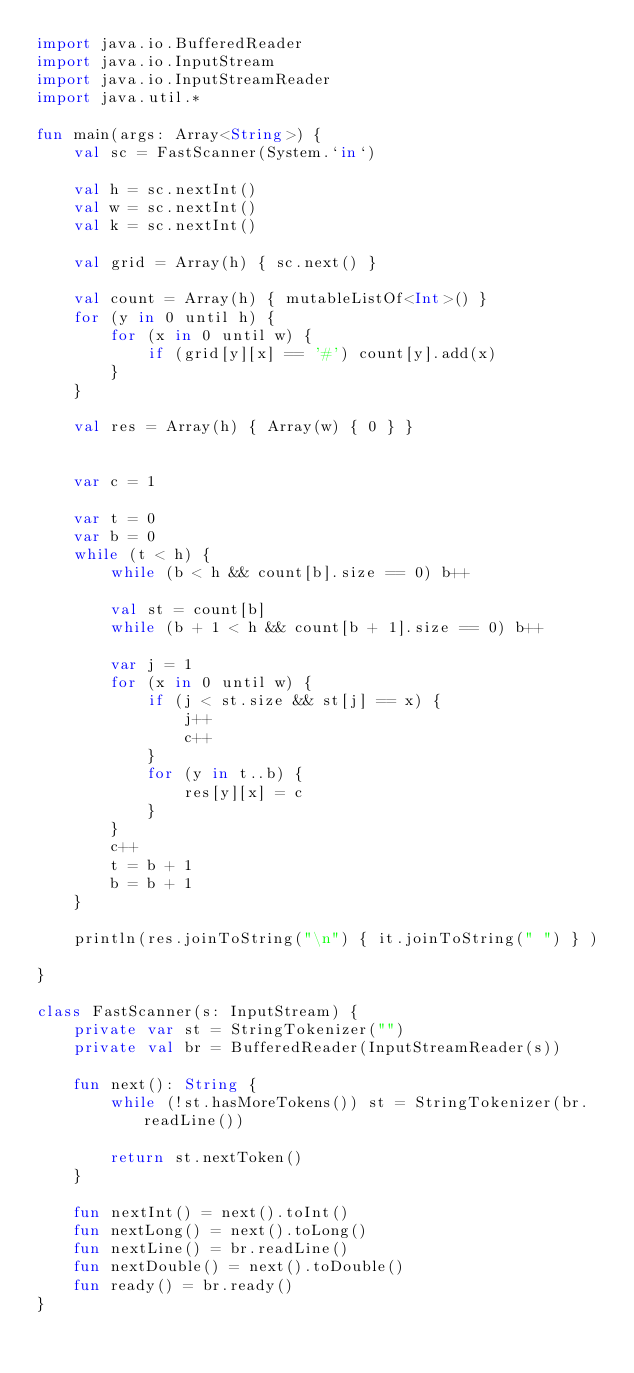<code> <loc_0><loc_0><loc_500><loc_500><_Kotlin_>import java.io.BufferedReader
import java.io.InputStream
import java.io.InputStreamReader
import java.util.*

fun main(args: Array<String>) {
    val sc = FastScanner(System.`in`)

    val h = sc.nextInt()
    val w = sc.nextInt()
    val k = sc.nextInt()

    val grid = Array(h) { sc.next() }

    val count = Array(h) { mutableListOf<Int>() }
    for (y in 0 until h) {
        for (x in 0 until w) {
            if (grid[y][x] == '#') count[y].add(x)
        }
    }

    val res = Array(h) { Array(w) { 0 } }


    var c = 1

    var t = 0
    var b = 0
    while (t < h) {
        while (b < h && count[b].size == 0) b++

        val st = count[b]
        while (b + 1 < h && count[b + 1].size == 0) b++

        var j = 1
        for (x in 0 until w) {
            if (j < st.size && st[j] == x) {
                j++
                c++
            }
            for (y in t..b) {
                res[y][x] = c
            }
        }
        c++
        t = b + 1
        b = b + 1
    }

    println(res.joinToString("\n") { it.joinToString(" ") } )

}

class FastScanner(s: InputStream) {
    private var st = StringTokenizer("")
    private val br = BufferedReader(InputStreamReader(s))

    fun next(): String {
        while (!st.hasMoreTokens()) st = StringTokenizer(br.readLine())

        return st.nextToken()
    }

    fun nextInt() = next().toInt()
    fun nextLong() = next().toLong()
    fun nextLine() = br.readLine()
    fun nextDouble() = next().toDouble()
    fun ready() = br.ready()
}</code> 